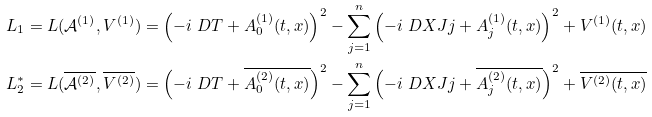Convert formula to latex. <formula><loc_0><loc_0><loc_500><loc_500>L _ { 1 } = L ( \mathcal { A } ^ { ( 1 ) } , V ^ { ( 1 ) } ) & = \left ( - i \ D T + A _ { 0 } ^ { ( 1 ) } ( t , x ) \right ) ^ { 2 } - \sum _ { j = 1 } ^ { n } \left ( - i \ D X J { j } + A _ { j } ^ { ( 1 ) } ( t , x ) \right ) ^ { 2 } + V ^ { ( 1 ) } ( t , x ) \\ L _ { 2 } ^ { * } = L ( \overline { \mathcal { A } ^ { ( 2 ) } } , \overline { V ^ { ( 2 ) } } ) & = \left ( - i \ D T + \overline { A _ { 0 } ^ { ( 2 ) } ( t , x ) } \right ) ^ { 2 } - \sum _ { j = 1 } ^ { n } \left ( - i \ D X J { j } + \overline { A _ { j } ^ { ( 2 ) } ( t , x ) } \right ) ^ { 2 } + \overline { V ^ { ( 2 ) } ( t , x ) }</formula> 